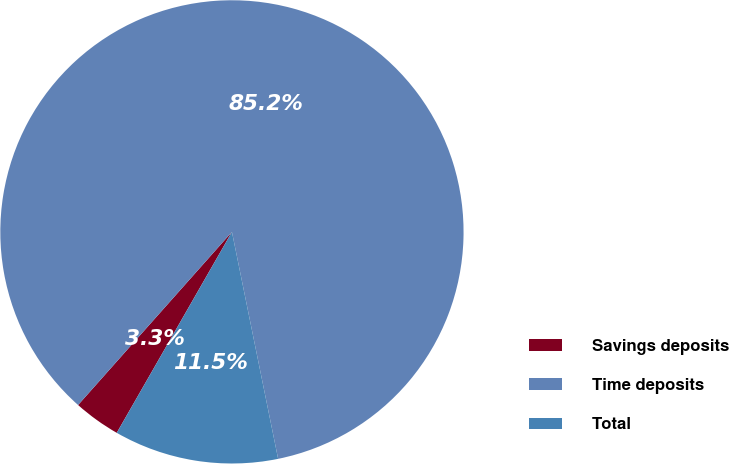<chart> <loc_0><loc_0><loc_500><loc_500><pie_chart><fcel>Savings deposits<fcel>Time deposits<fcel>Total<nl><fcel>3.28%<fcel>85.25%<fcel>11.48%<nl></chart> 